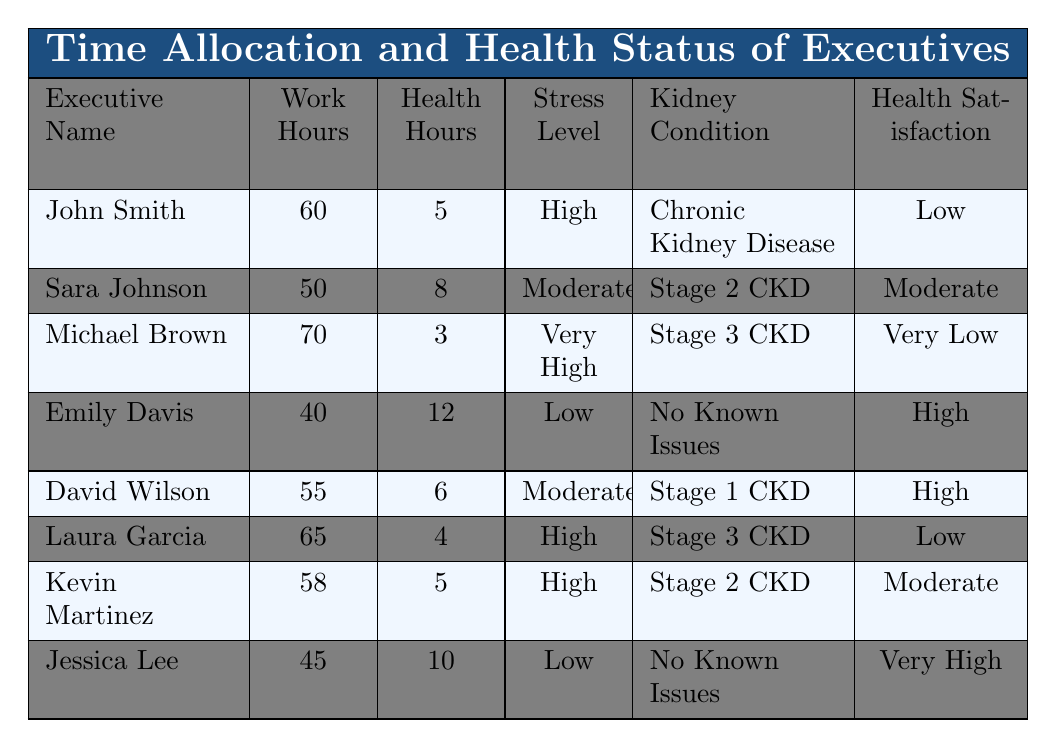What is the maximum number of work hours reported by any executive? The table shows the work hours for each executive. By reviewing the "Work Hours" column, we identify Michael Brown with 70 work hours per week, which is the highest.
Answer: 70 What is the average health activities hours per week among all executives? To find the average, we sum the health activities hours: (5 + 8 + 3 + 12 + 6 + 4 + 5 + 10) = 53. There are 8 executives, so the average is 53 / 8 = 6.625.
Answer: 6.625 Is Jessica Lee's stress level low? The table indicates Jessica Lee has a stress level labeled as "Low." Therefore, the statement is true.
Answer: Yes Which executive has the highest satisfaction with health? By analyzing the "Health Satisfaction" column, Emily Davis is noted with "High" satisfaction, as well as David Wilson. However, Jessica Lee has "Very High" satisfaction, which is the highest observed.
Answer: Jessica Lee Are there any executives with a very low satisfaction with health? Based on the table, Michael Brown and Laura Garcia have "Very Low" and "Low" satisfaction respectively, confirming that yes, there are executives with very low satisfaction.
Answer: Yes How does the work hour allocation relate to health satisfaction? By examining the data, we notice a pattern: Emily Davis, who works 40 hours with high health activity hours (12), has high satisfaction. Conversely, both John Smith and Michael Brown, with high work hours (60 and 70 respectively) experience low satisfaction. This suggests that higher work hours correlate with lower health satisfaction.
Answer: Higher work hours correlate with lower health satisfaction What is the stress level of executives who have Stage 3 CKD? The table shows that both Michael Brown and Laura Garcia, who have Stage 3 CKD, report stress levels of "Very High" and "High," respectively.
Answer: Very High and High How many executives work more than 55 hours a week and report a high stress level? Examining the entries, John Smith (60 hours, High stress) and Laura Garcia (65 hours, High stress) meet this criterion. Thus, 2 executives fulfill the condition of working more than 55 hours and having a high stress level.
Answer: 2 